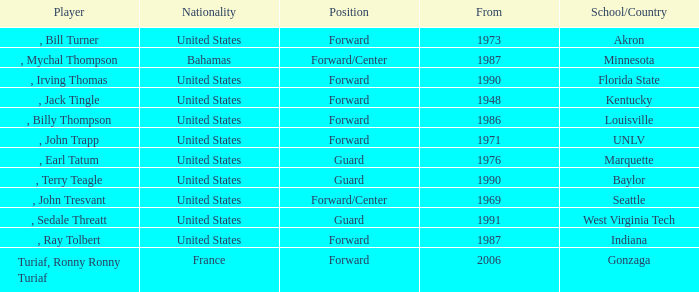What was the nationality of every player that attended Baylor? United States. 